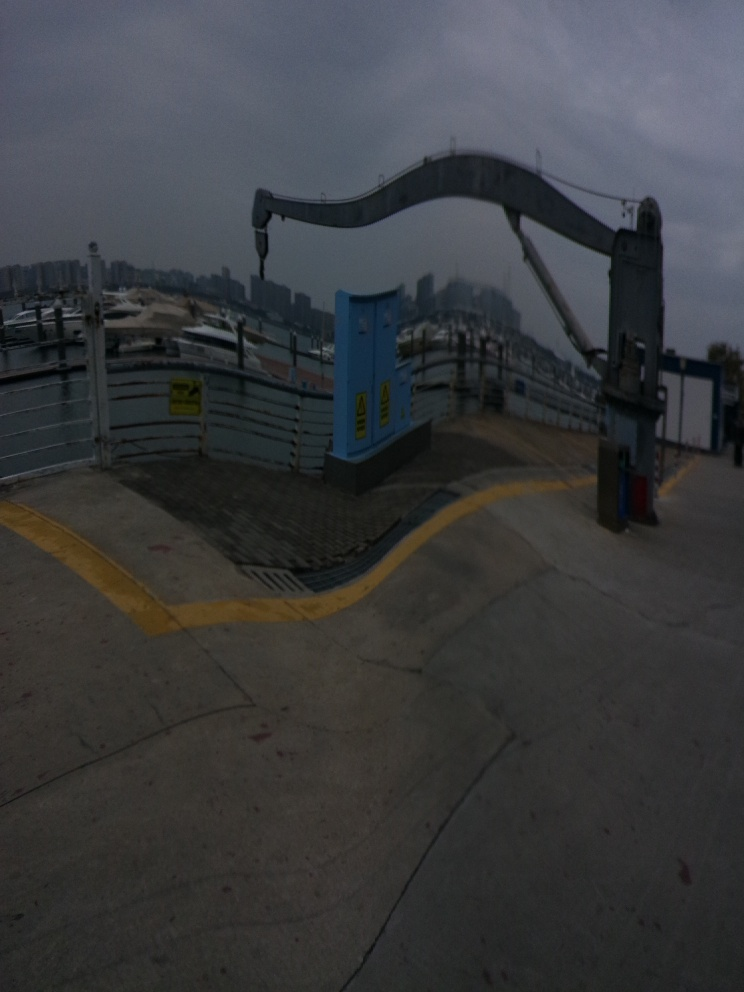How would you describe the composition of this image? The image features an outdoor urban environment with an overcast sky. There's a large industrial-looking device, possibly a crane or loading mechanism, dominating the left side of the frame. Concrete grounds with yellow safety lines draw the eye towards this machinery. The background showcases a cityscape with numerous buildings, hinting at a densely populated area. The lighting suggests either early morning or late afternoon, creating a somewhat gloomy atmosphere. 